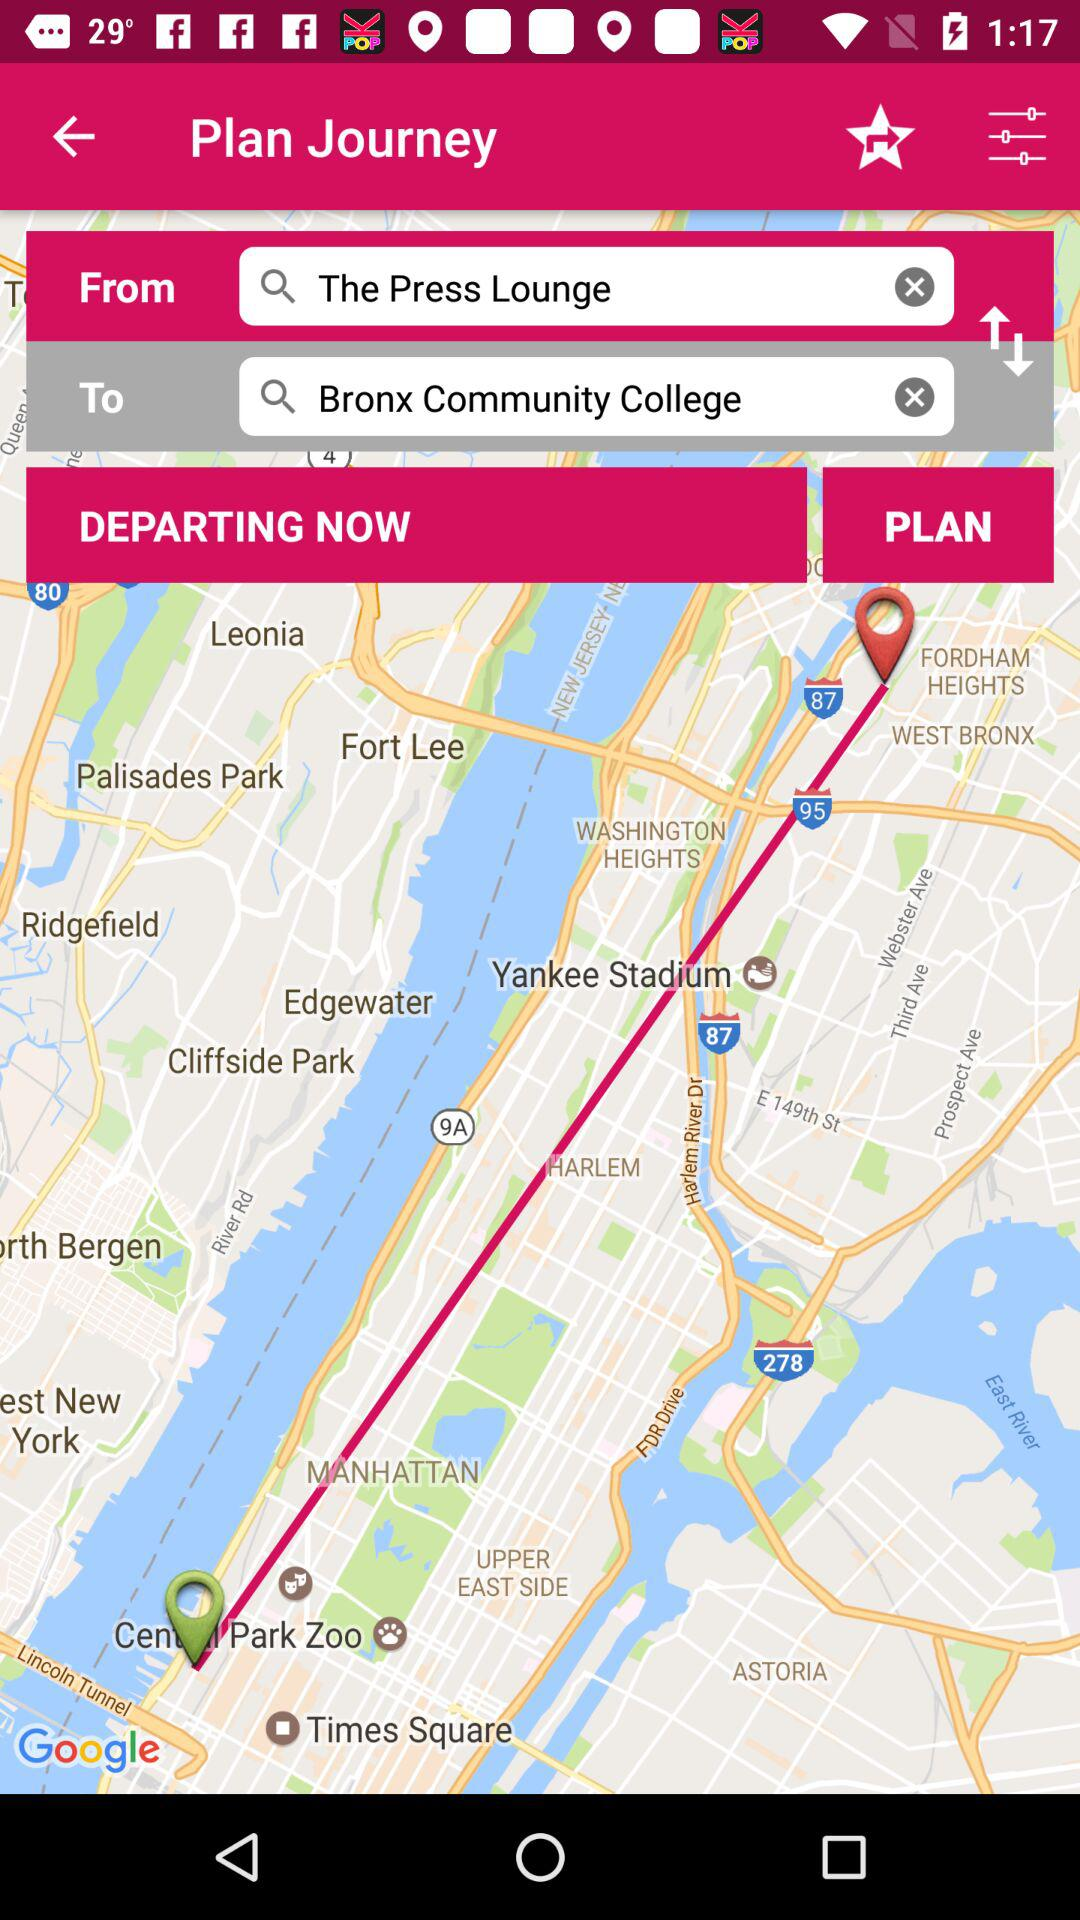Where does the journey plan start from? The journey plan starts from "The Press Lounge". 